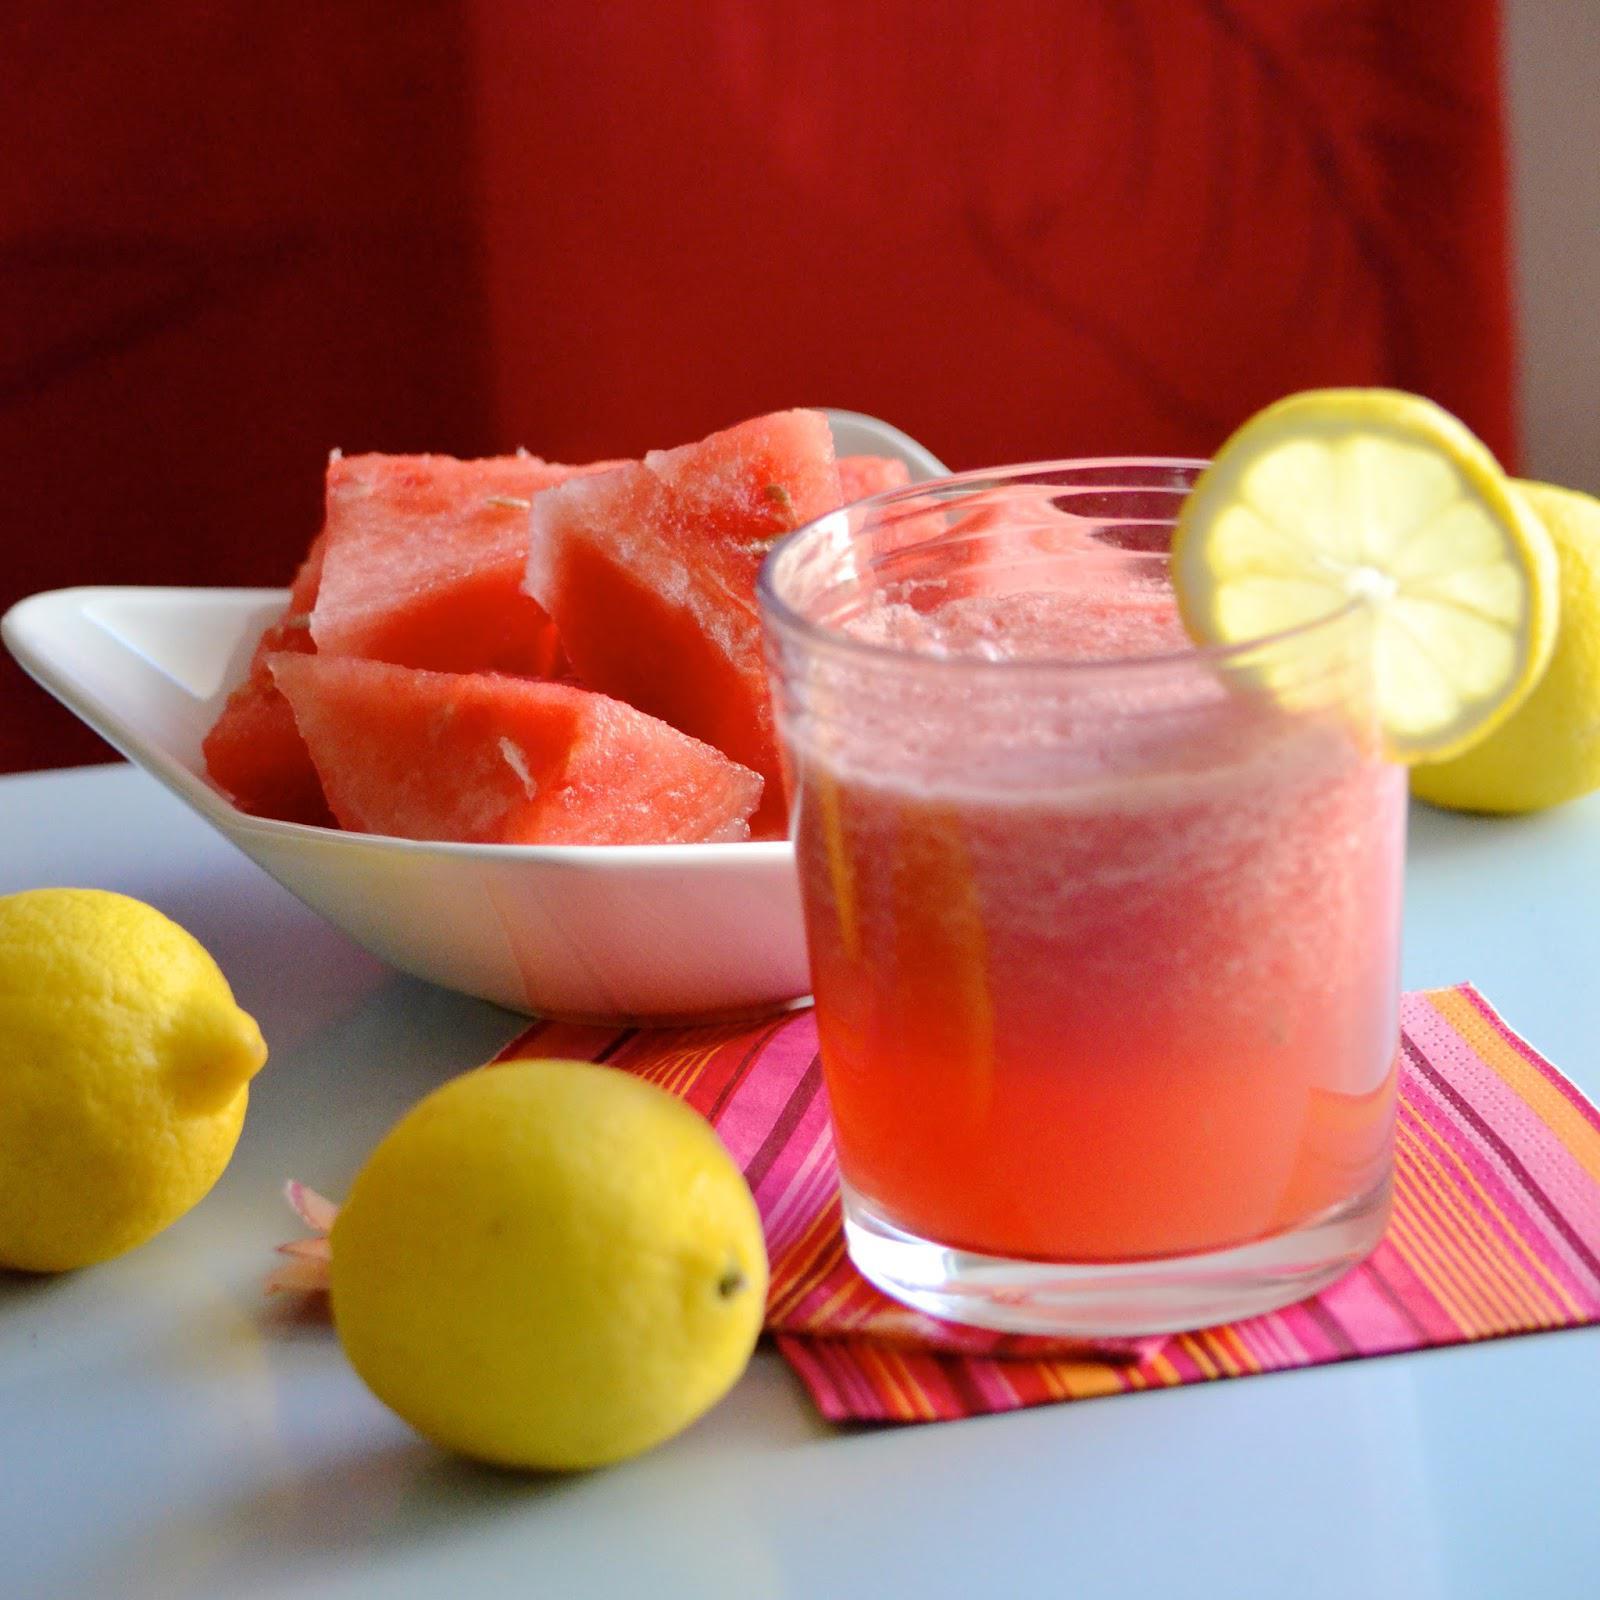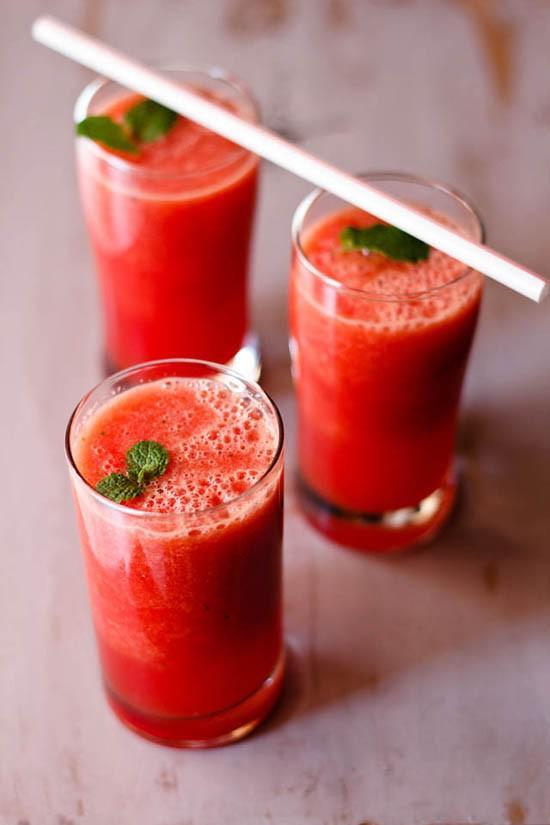The first image is the image on the left, the second image is the image on the right. For the images displayed, is the sentence "There is more than one slice of lemon in the image on the left" factually correct? Answer yes or no. No. The first image is the image on the left, the second image is the image on the right. Considering the images on both sides, is "Left and right images show the same number of prepared drinks in serving cups." valid? Answer yes or no. No. 